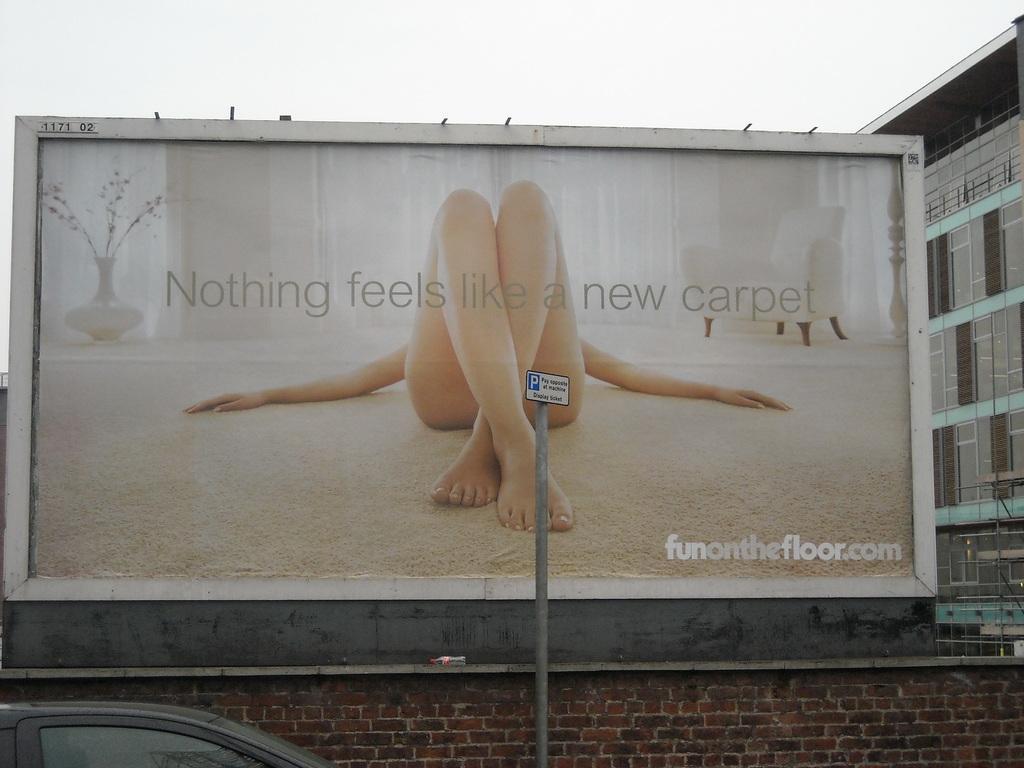How would you summarize this image in a sentence or two? In this image we can see a banner. On banner we can see some text written and a woman is lying on the floor. At the bottom of the image, one pole, brick wall and car is there. Right side of the image, building is present. At the top of the image, sky is there which is in white color. 